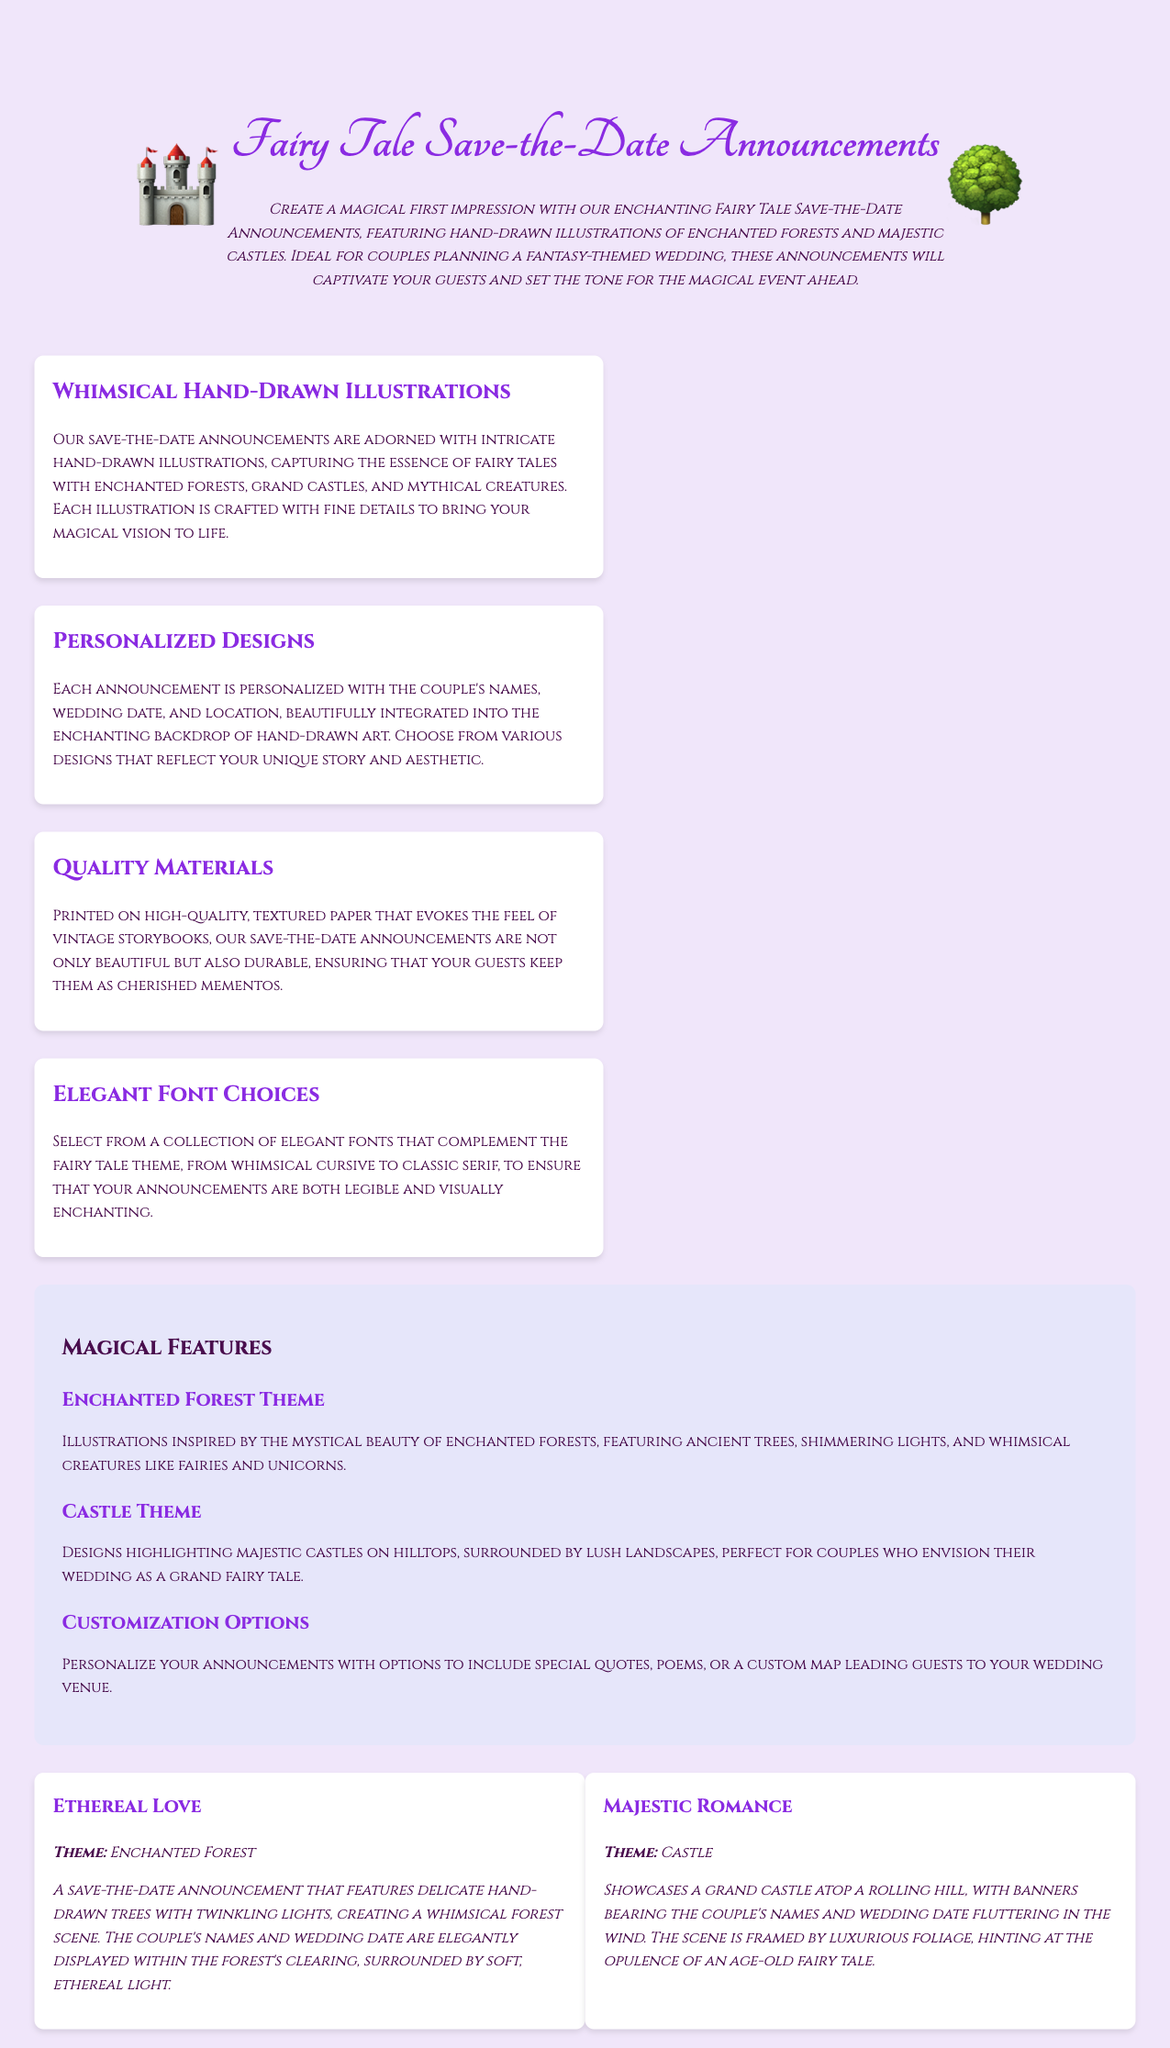What are the illustrations featured on the announcements? The announcements feature hand-drawn illustrations of enchanted forests and majestic castles.
Answer: enchanted forests and majestic castles What is the theme of the "Ethereal Love" announcement? The "Ethereal Love" announcement revolves around the enchanted forest theme.
Answer: Enchanted Forest How are the save-the-date announcements printed? They are printed on high-quality, textured paper that evokes the feel of vintage storybooks.
Answer: high-quality, textured paper What customization options are available for the announcements? Options include including special quotes, poems, or a custom map leading guests to the venue.
Answer: special quotes, poems, or a custom map Which font styles are offered for the announcements? A collection of elegant fonts ranging from whimsical cursive to classic serif is offered.
Answer: elegant fonts What decorative elements are included in the "Majestic Romance" theme? It features a grand castle, banners, and luxurious foliage surrounding the scene.
Answer: grand castle, banners, and luxurious foliage How many examples of announcements are provided in the document? There are two examples of announcements provided.
Answer: two What color theme is used in the document for text and background? The document uses a combination of purple text color over a light lavender background.
Answer: purple text color over a light lavender background What is the purpose of the featured announcements? They are designed to create a magical first impression for couples planning a fantasy-themed wedding.
Answer: magical first impression for couples planning a fantasy-themed wedding 